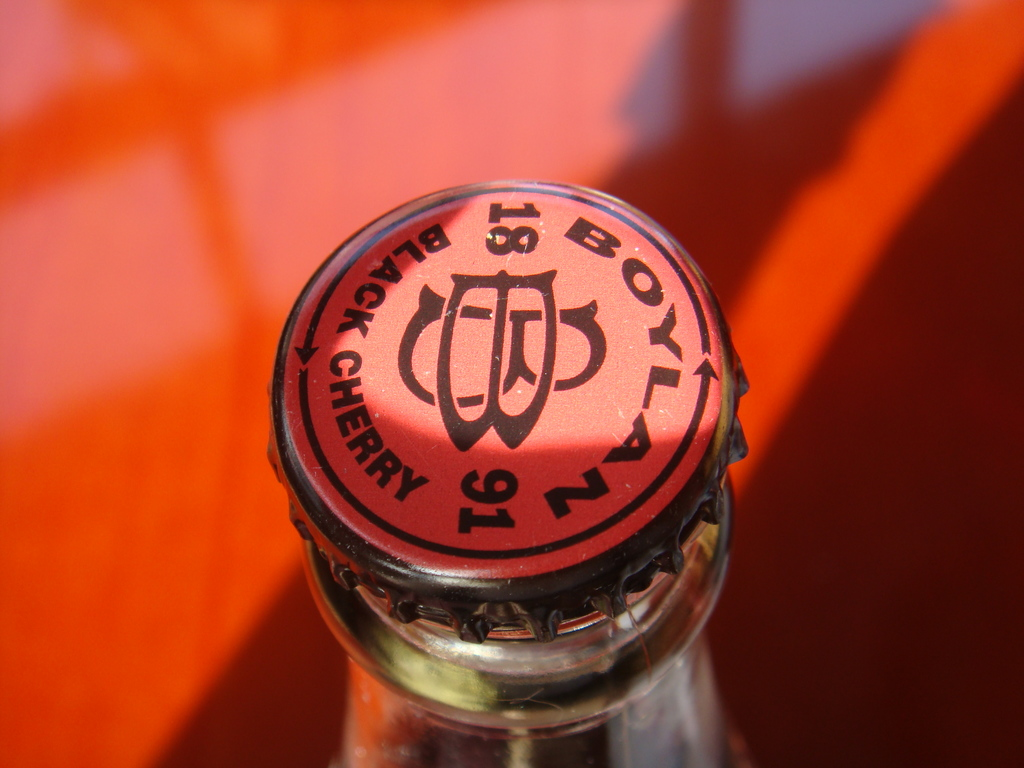Can you tell more about how the orange background affects the perception of the red cap? The orange background in the image complements the red cap, creating a warm and appealing color palette. This background not only highlights the cap but also enhances the overall allure of the product, drawing attention to the vividness of the cherry-flavored beverage it caps. The play between these two colors can evoke feelings of energy and excitement, potentially appealing to consumer emotions and increasing product attraction. 